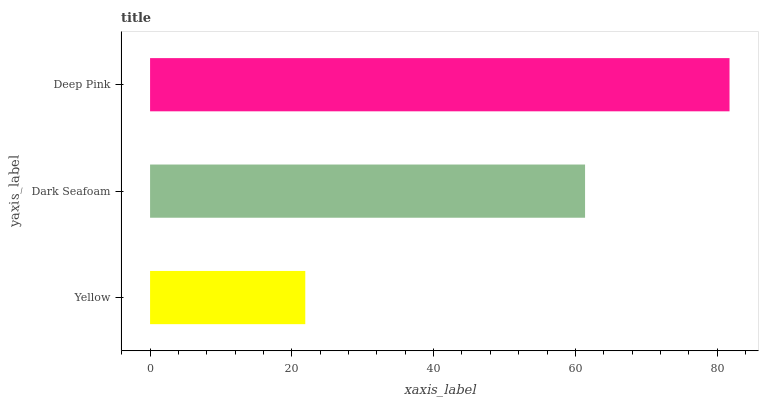Is Yellow the minimum?
Answer yes or no. Yes. Is Deep Pink the maximum?
Answer yes or no. Yes. Is Dark Seafoam the minimum?
Answer yes or no. No. Is Dark Seafoam the maximum?
Answer yes or no. No. Is Dark Seafoam greater than Yellow?
Answer yes or no. Yes. Is Yellow less than Dark Seafoam?
Answer yes or no. Yes. Is Yellow greater than Dark Seafoam?
Answer yes or no. No. Is Dark Seafoam less than Yellow?
Answer yes or no. No. Is Dark Seafoam the high median?
Answer yes or no. Yes. Is Dark Seafoam the low median?
Answer yes or no. Yes. Is Yellow the high median?
Answer yes or no. No. Is Deep Pink the low median?
Answer yes or no. No. 